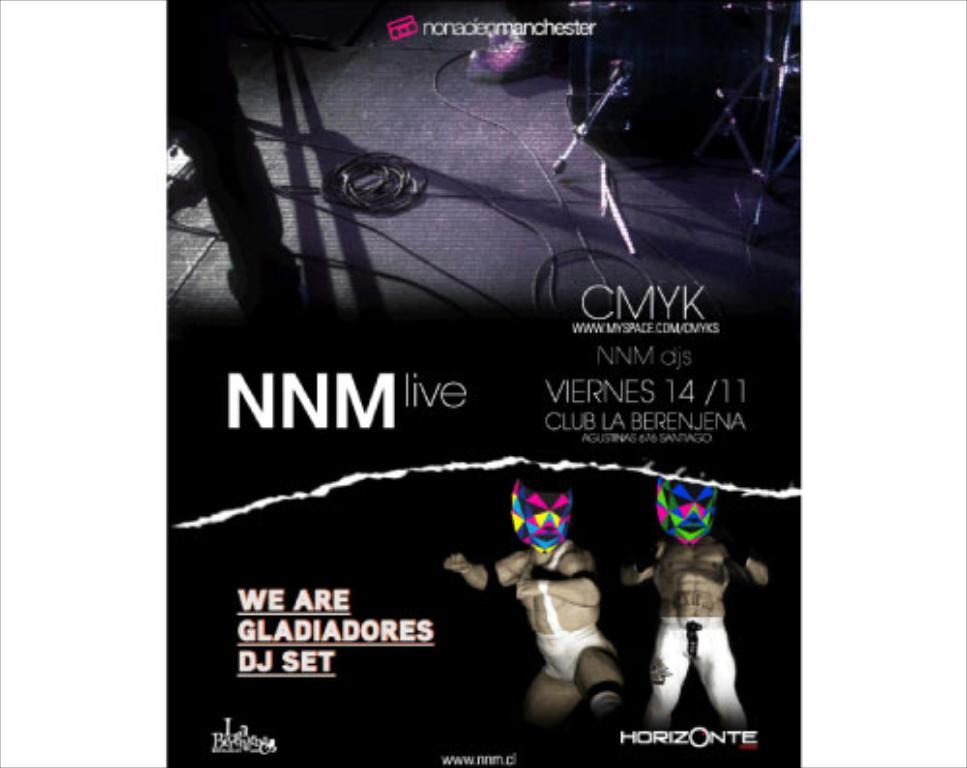<image>
Provide a brief description of the given image. Poster that says NNM Live showing two tiny wrestlers. 